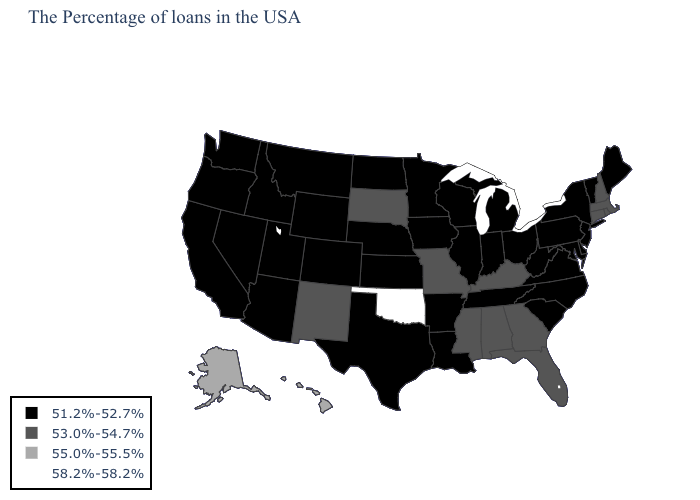Which states hav the highest value in the West?
Keep it brief. Alaska, Hawaii. Among the states that border Vermont , which have the lowest value?
Be succinct. New York. What is the value of Oregon?
Quick response, please. 51.2%-52.7%. Name the states that have a value in the range 51.2%-52.7%?
Write a very short answer. Maine, Vermont, New York, New Jersey, Delaware, Maryland, Pennsylvania, Virginia, North Carolina, South Carolina, West Virginia, Ohio, Michigan, Indiana, Tennessee, Wisconsin, Illinois, Louisiana, Arkansas, Minnesota, Iowa, Kansas, Nebraska, Texas, North Dakota, Wyoming, Colorado, Utah, Montana, Arizona, Idaho, Nevada, California, Washington, Oregon. What is the value of Vermont?
Quick response, please. 51.2%-52.7%. Which states have the lowest value in the USA?
Quick response, please. Maine, Vermont, New York, New Jersey, Delaware, Maryland, Pennsylvania, Virginia, North Carolina, South Carolina, West Virginia, Ohio, Michigan, Indiana, Tennessee, Wisconsin, Illinois, Louisiana, Arkansas, Minnesota, Iowa, Kansas, Nebraska, Texas, North Dakota, Wyoming, Colorado, Utah, Montana, Arizona, Idaho, Nevada, California, Washington, Oregon. Which states have the highest value in the USA?
Keep it brief. Oklahoma. Name the states that have a value in the range 51.2%-52.7%?
Be succinct. Maine, Vermont, New York, New Jersey, Delaware, Maryland, Pennsylvania, Virginia, North Carolina, South Carolina, West Virginia, Ohio, Michigan, Indiana, Tennessee, Wisconsin, Illinois, Louisiana, Arkansas, Minnesota, Iowa, Kansas, Nebraska, Texas, North Dakota, Wyoming, Colorado, Utah, Montana, Arizona, Idaho, Nevada, California, Washington, Oregon. What is the highest value in states that border California?
Give a very brief answer. 51.2%-52.7%. What is the value of Minnesota?
Short answer required. 51.2%-52.7%. What is the value of New Mexico?
Short answer required. 53.0%-54.7%. What is the value of Kansas?
Quick response, please. 51.2%-52.7%. Does the first symbol in the legend represent the smallest category?
Concise answer only. Yes. Name the states that have a value in the range 53.0%-54.7%?
Write a very short answer. Massachusetts, Rhode Island, New Hampshire, Connecticut, Florida, Georgia, Kentucky, Alabama, Mississippi, Missouri, South Dakota, New Mexico. 